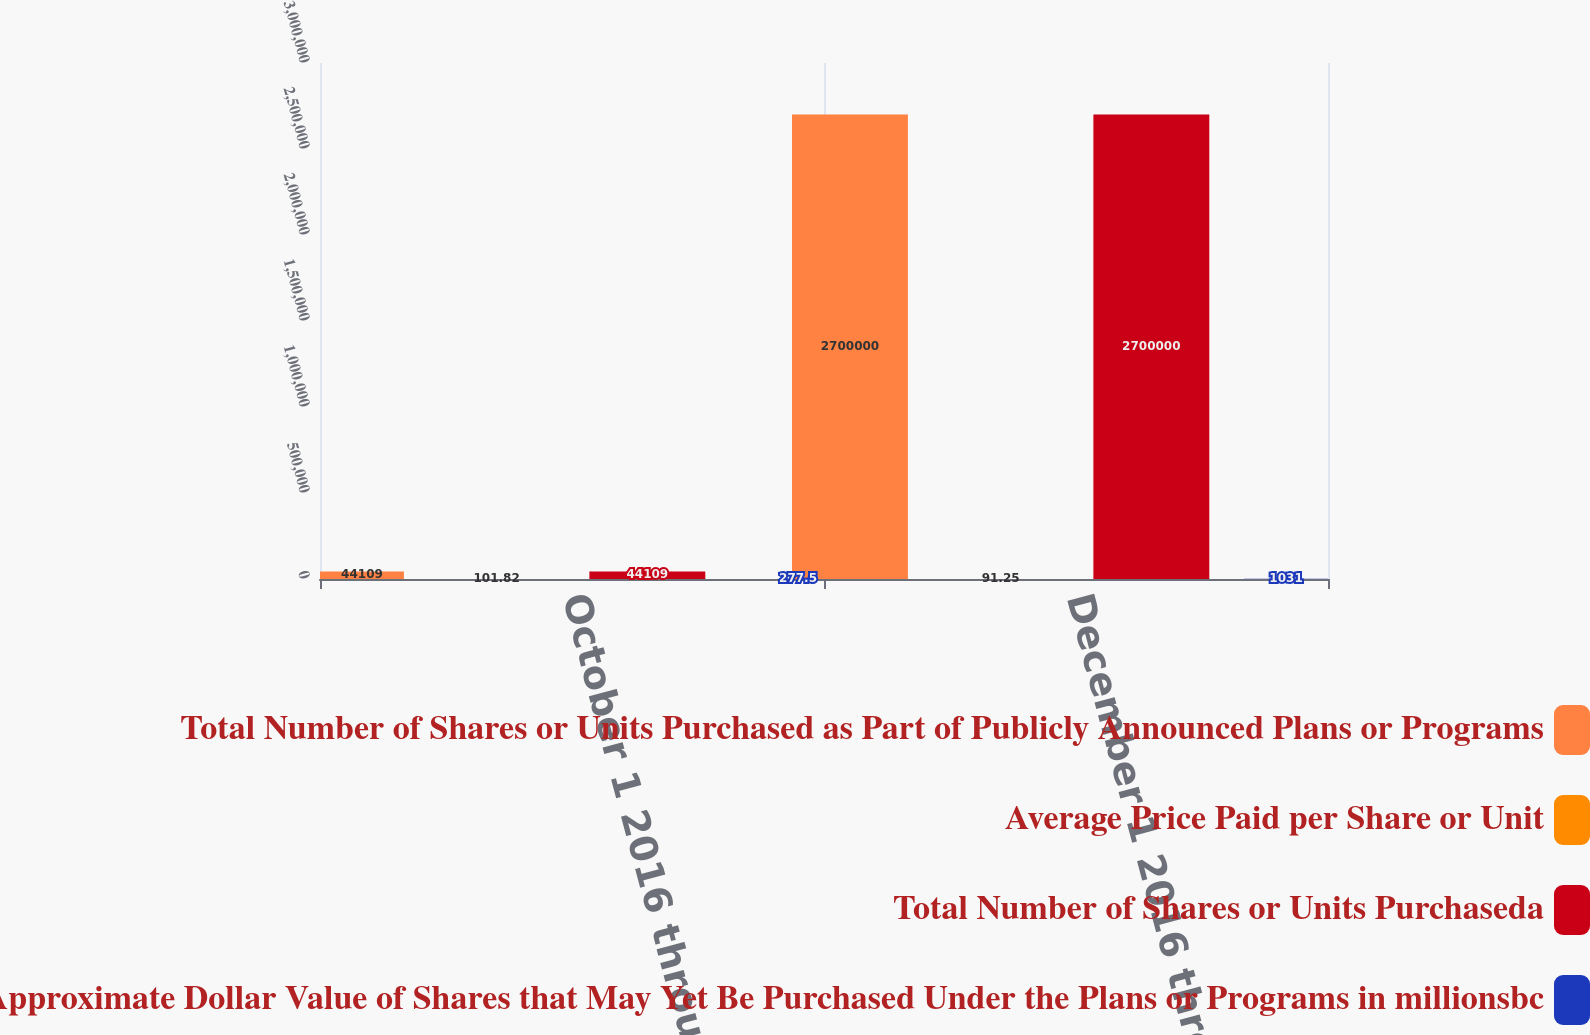Convert chart to OTSL. <chart><loc_0><loc_0><loc_500><loc_500><stacked_bar_chart><ecel><fcel>October 1 2016 through October<fcel>December 1 2016 through<nl><fcel>Total Number of Shares or Units Purchased as Part of Publicly Announced Plans or Programs<fcel>44109<fcel>2.7e+06<nl><fcel>Average Price Paid per Share or Unit<fcel>101.82<fcel>91.25<nl><fcel>Total Number of Shares or Units Purchaseda<fcel>44109<fcel>2.7e+06<nl><fcel>Maximum Number or Approximate Dollar Value of Shares that May Yet Be Purchased Under the Plans or Programs in millionsbc<fcel>277.5<fcel>1031<nl></chart> 